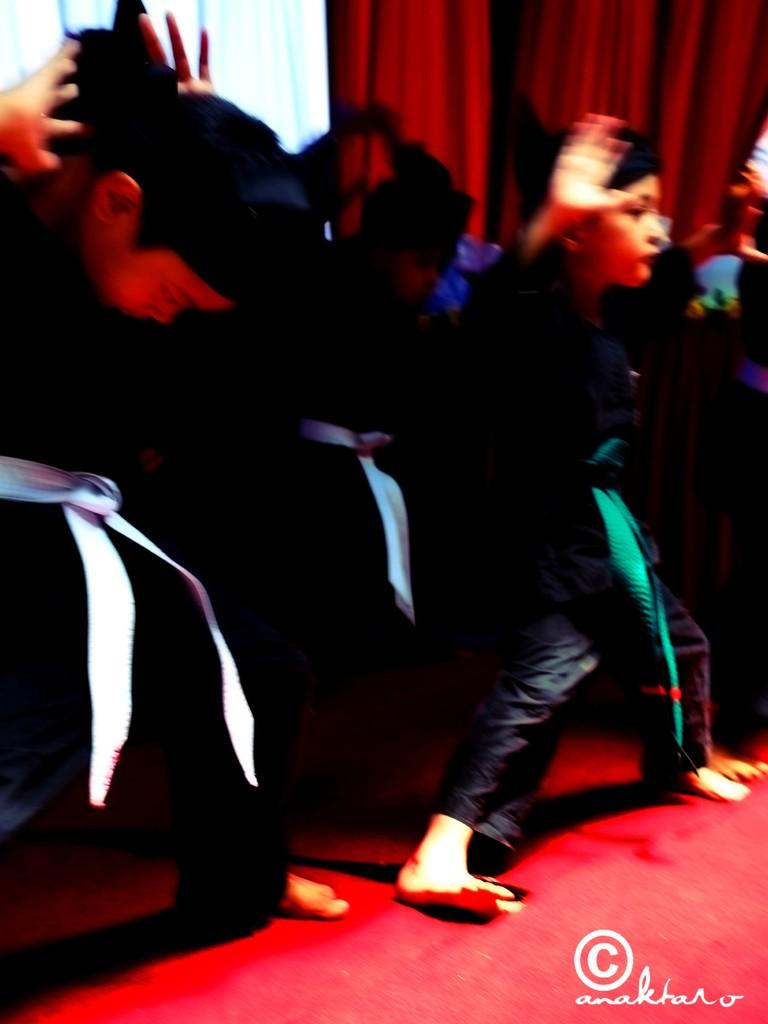What is happening on the stage in the image? There are people standing on the stage in the image. What can be seen in the background of the stage? There are curtains in the background of the image. Where is the text located in the image? The text is at the bottom right side of the image. What type of frog is sitting on the cake in the image? There is no frog or cake present in the image. 